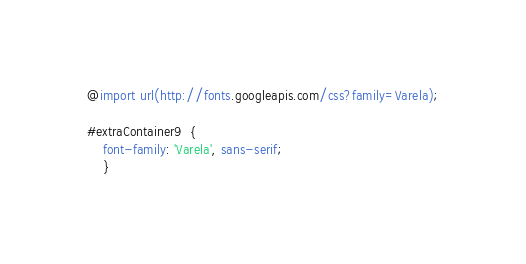<code> <loc_0><loc_0><loc_500><loc_500><_CSS_>@import url(http://fonts.googleapis.com/css?family=Varela);

#extraContainer9  {
	font-family: 'Varela', sans-serif;
	}</code> 